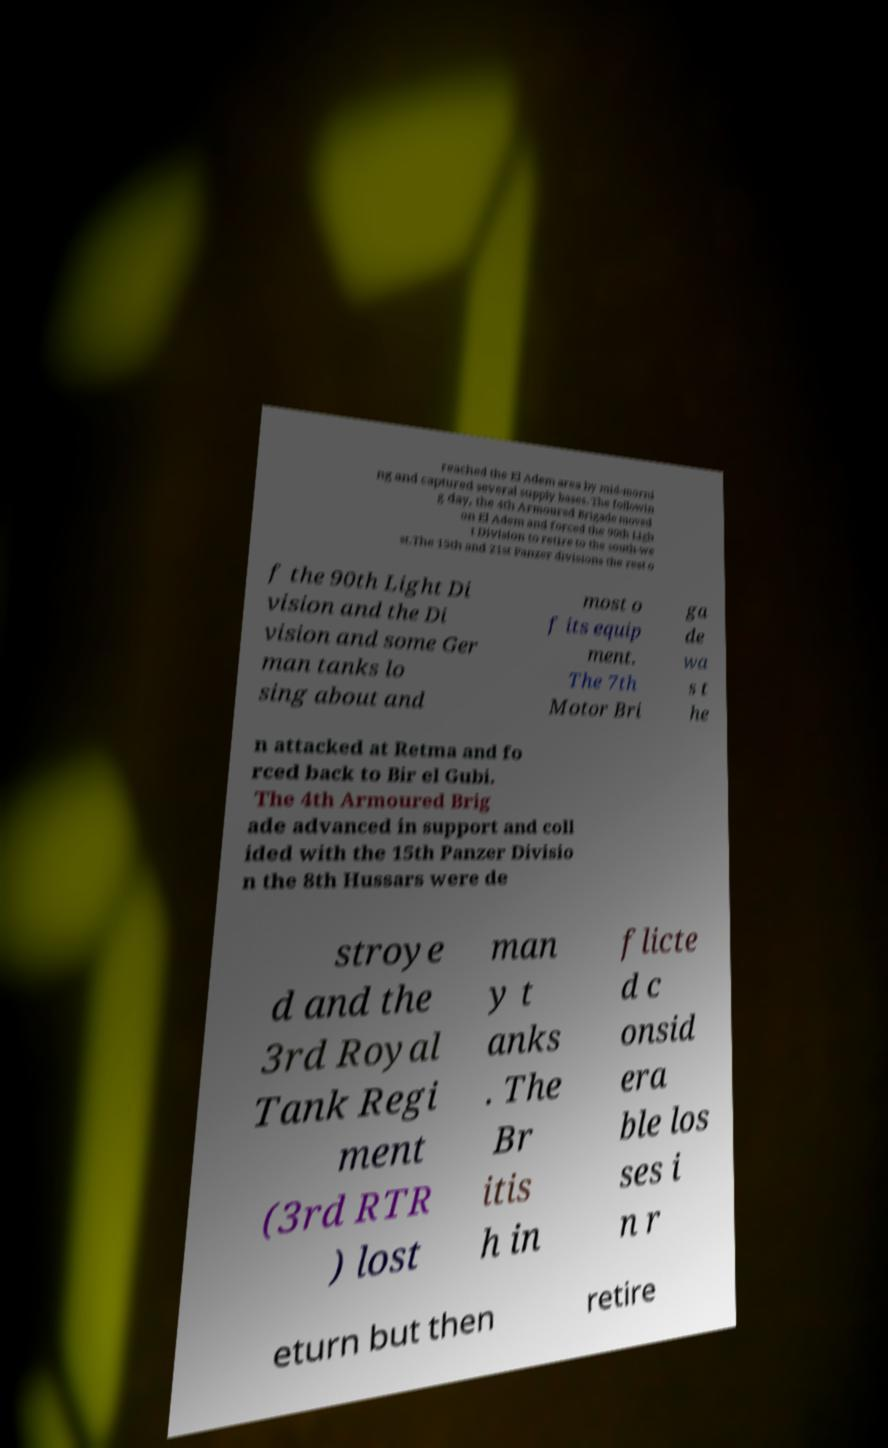There's text embedded in this image that I need extracted. Can you transcribe it verbatim? reached the El Adem area by mid-morni ng and captured several supply bases. The followin g day, the 4th Armoured Brigade moved on El Adem and forced the 90th Ligh t Division to retire to the south-we st.The 15th and 21st Panzer divisions the rest o f the 90th Light Di vision and the Di vision and some Ger man tanks lo sing about and most o f its equip ment. The 7th Motor Bri ga de wa s t he n attacked at Retma and fo rced back to Bir el Gubi. The 4th Armoured Brig ade advanced in support and coll ided with the 15th Panzer Divisio n the 8th Hussars were de stroye d and the 3rd Royal Tank Regi ment (3rd RTR ) lost man y t anks . The Br itis h in flicte d c onsid era ble los ses i n r eturn but then retire 